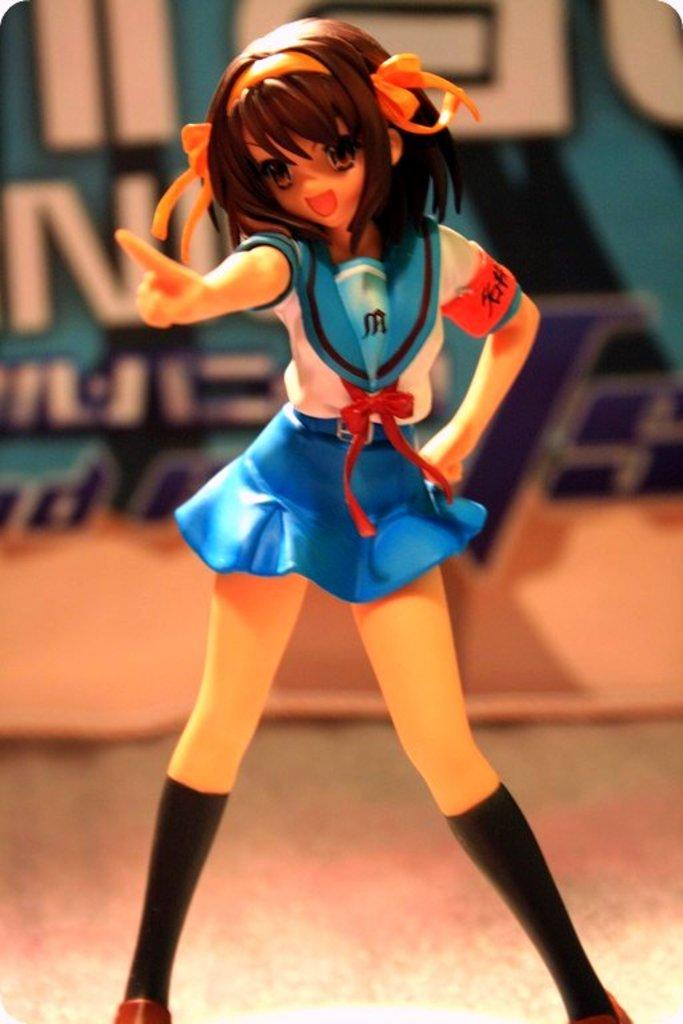What object in the image is designed for play or entertainment? There is a toy in the image. What type of language is spoken by the toy in the image? The toy in the image does not speak any language, as it is an inanimate object. What type of dinner is being served with the wine in the image? There is no dinner or wine present in the image; it only features a toy. 